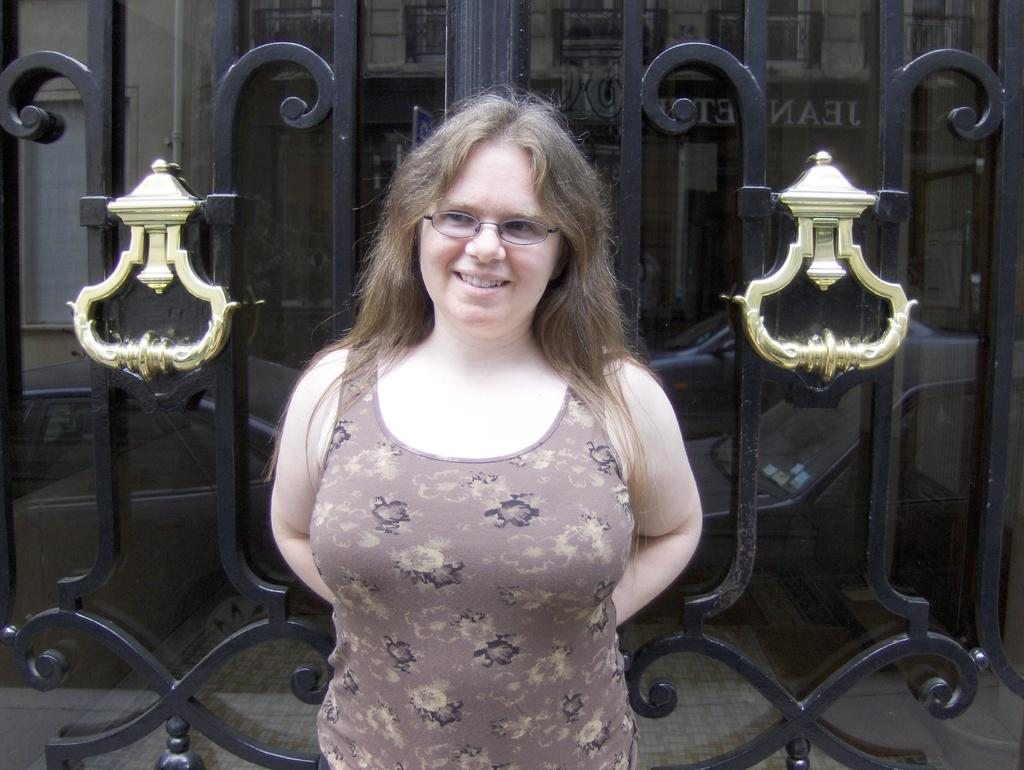What is the main subject of the image? There is a person standing in the image. Can you describe the person's clothing? The person is wearing a brown shirt. What can be seen in the background of the image? There is a gate and a building in the background of the image. What colors are the gate and building? The gate is black, and the building is gray. How many bikes are parked near the person in the image? There are no bikes visible in the image. What type of truck can be seen driving past the building in the image? There is no truck present in the image. 